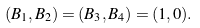Convert formula to latex. <formula><loc_0><loc_0><loc_500><loc_500>( B _ { 1 } , B _ { 2 } ) = ( B _ { 3 } , B _ { 4 } ) = ( 1 , 0 ) .</formula> 